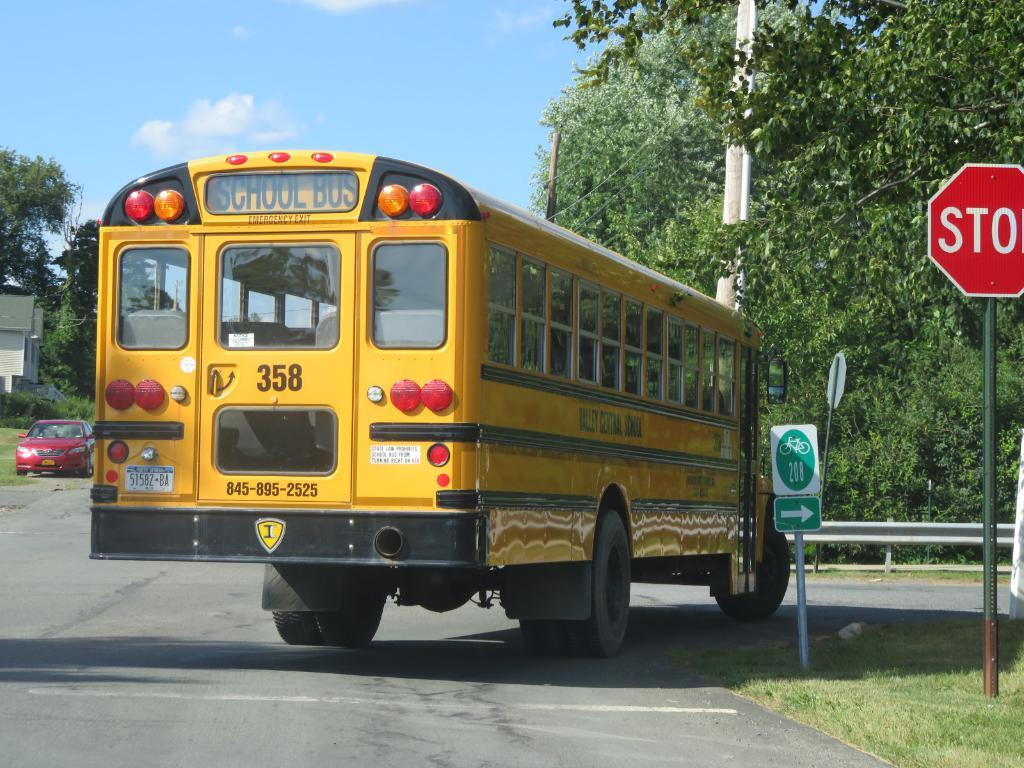What type of vehicle is on the road in the image? There is a bus on the road in the image. What other vehicle can be seen in the image? There is a car on the left side of the image. What is located on the right side of the image? There are boards on the right side of the image. What can be seen in the background of the image? Trees, the sky, and a building are visible in the background of the image. What type of birthday cake is being served at the dinner in the image? There is no birthday cake or dinner present in the image; it features a bus, a car, boards, trees, the sky, and a building. 